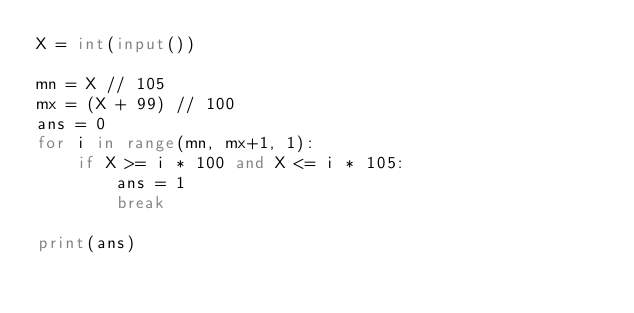Convert code to text. <code><loc_0><loc_0><loc_500><loc_500><_Python_>X = int(input())

mn = X // 105
mx = (X + 99) // 100
ans = 0
for i in range(mn, mx+1, 1):
    if X >= i * 100 and X <= i * 105:
        ans = 1
        break

print(ans)
</code> 